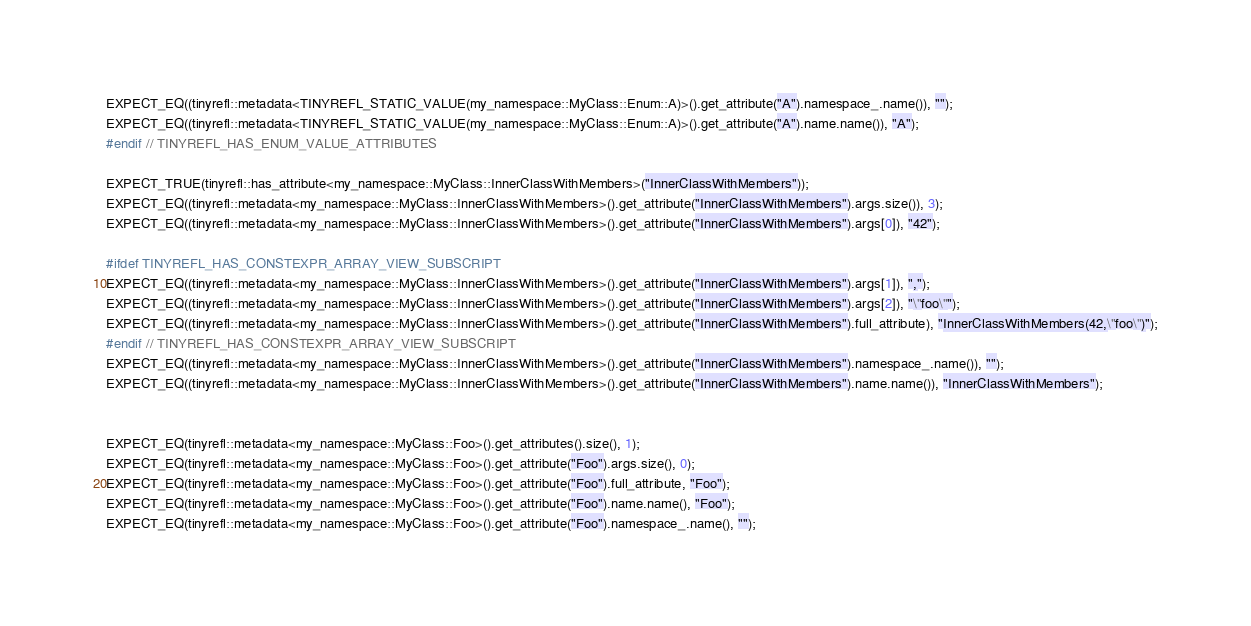Convert code to text. <code><loc_0><loc_0><loc_500><loc_500><_C++_>EXPECT_EQ((tinyrefl::metadata<TINYREFL_STATIC_VALUE(my_namespace::MyClass::Enum::A)>().get_attribute("A").namespace_.name()), "");
EXPECT_EQ((tinyrefl::metadata<TINYREFL_STATIC_VALUE(my_namespace::MyClass::Enum::A)>().get_attribute("A").name.name()), "A");
#endif // TINYREFL_HAS_ENUM_VALUE_ATTRIBUTES

EXPECT_TRUE(tinyrefl::has_attribute<my_namespace::MyClass::InnerClassWithMembers>("InnerClassWithMembers"));
EXPECT_EQ((tinyrefl::metadata<my_namespace::MyClass::InnerClassWithMembers>().get_attribute("InnerClassWithMembers").args.size()), 3);
EXPECT_EQ((tinyrefl::metadata<my_namespace::MyClass::InnerClassWithMembers>().get_attribute("InnerClassWithMembers").args[0]), "42");

#ifdef TINYREFL_HAS_CONSTEXPR_ARRAY_VIEW_SUBSCRIPT
EXPECT_EQ((tinyrefl::metadata<my_namespace::MyClass::InnerClassWithMembers>().get_attribute("InnerClassWithMembers").args[1]), ",");
EXPECT_EQ((tinyrefl::metadata<my_namespace::MyClass::InnerClassWithMembers>().get_attribute("InnerClassWithMembers").args[2]), "\"foo\"");
EXPECT_EQ((tinyrefl::metadata<my_namespace::MyClass::InnerClassWithMembers>().get_attribute("InnerClassWithMembers").full_attribute), "InnerClassWithMembers(42,\"foo\")");
#endif // TINYREFL_HAS_CONSTEXPR_ARRAY_VIEW_SUBSCRIPT
EXPECT_EQ((tinyrefl::metadata<my_namespace::MyClass::InnerClassWithMembers>().get_attribute("InnerClassWithMembers").namespace_.name()), "");
EXPECT_EQ((tinyrefl::metadata<my_namespace::MyClass::InnerClassWithMembers>().get_attribute("InnerClassWithMembers").name.name()), "InnerClassWithMembers");


EXPECT_EQ(tinyrefl::metadata<my_namespace::MyClass::Foo>().get_attributes().size(), 1);
EXPECT_EQ(tinyrefl::metadata<my_namespace::MyClass::Foo>().get_attribute("Foo").args.size(), 0);
EXPECT_EQ(tinyrefl::metadata<my_namespace::MyClass::Foo>().get_attribute("Foo").full_attribute, "Foo");
EXPECT_EQ(tinyrefl::metadata<my_namespace::MyClass::Foo>().get_attribute("Foo").name.name(), "Foo");
EXPECT_EQ(tinyrefl::metadata<my_namespace::MyClass::Foo>().get_attribute("Foo").namespace_.name(), "");
</code> 